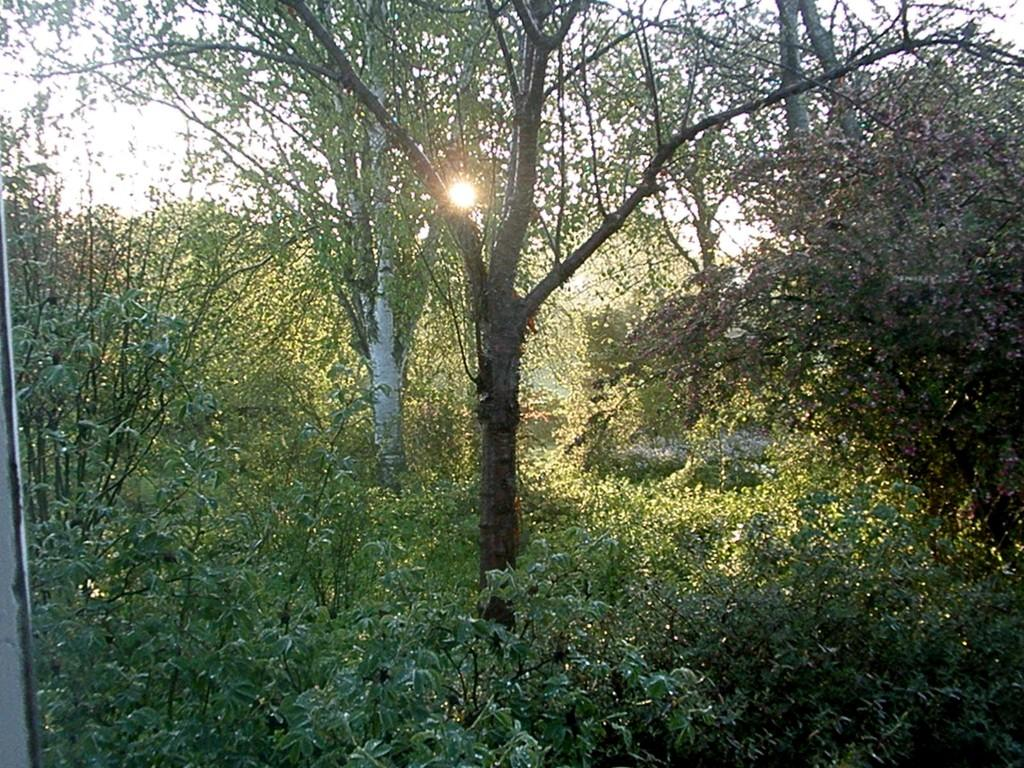What type of vegetation can be seen in the image? There are trees and plants in the image. What is the position of the sun in the image? The sun is visible between the trees in the image. What part of the natural environment is visible in the image? The sky is visible at the top of the image. What type of authority is present in the image? There is no authority figure present in the image; it features trees, plants, the sun, and the sky. What type of hall can be seen in the image? There is no hall present in the image; it features trees, plants, the sun, and the sky. 